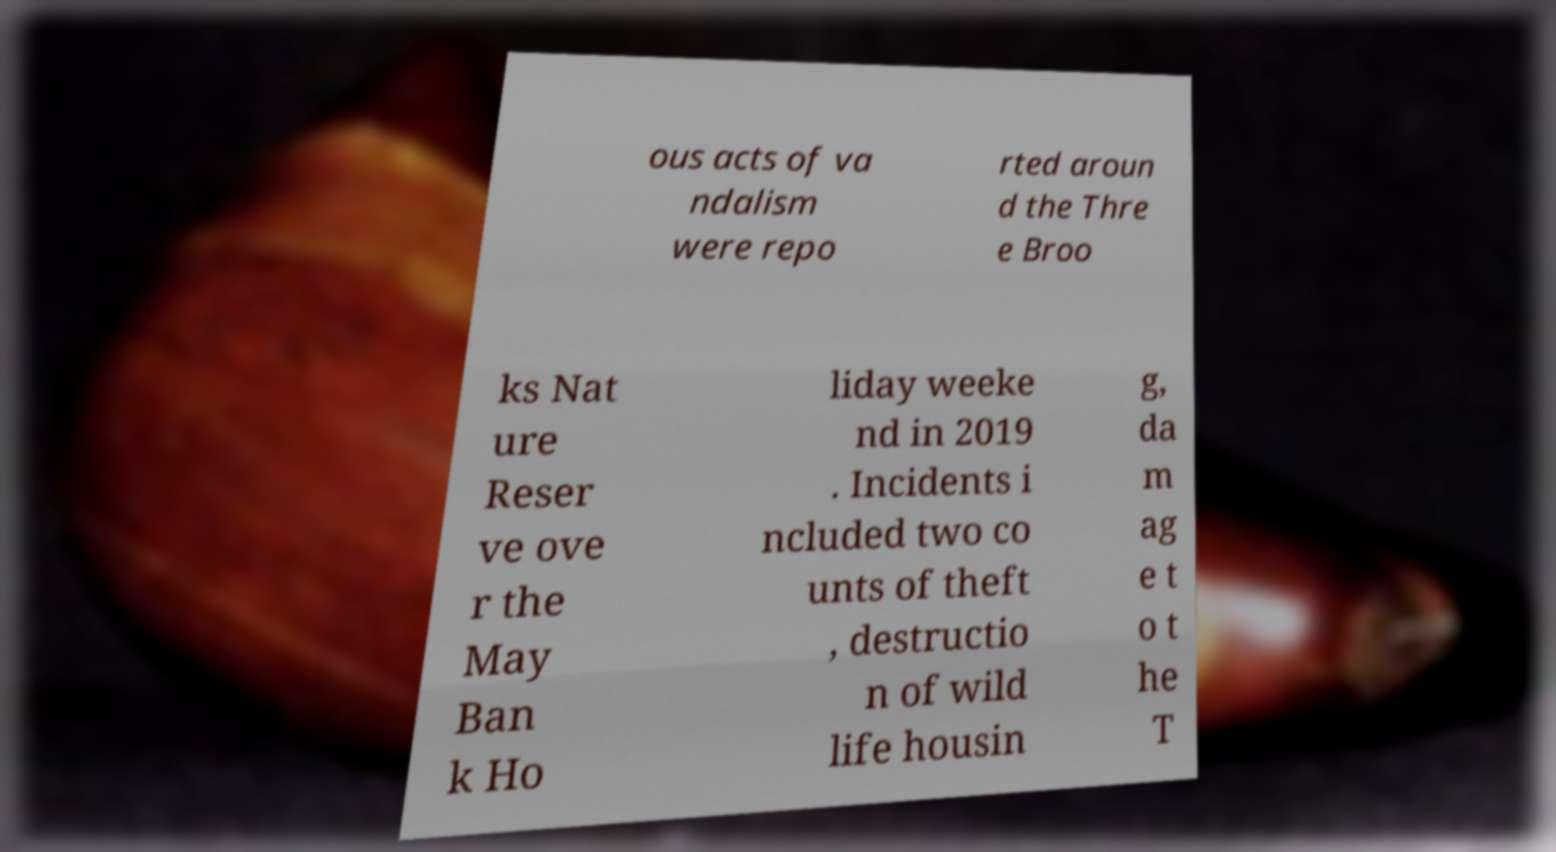There's text embedded in this image that I need extracted. Can you transcribe it verbatim? ous acts of va ndalism were repo rted aroun d the Thre e Broo ks Nat ure Reser ve ove r the May Ban k Ho liday weeke nd in 2019 . Incidents i ncluded two co unts of theft , destructio n of wild life housin g, da m ag e t o t he T 